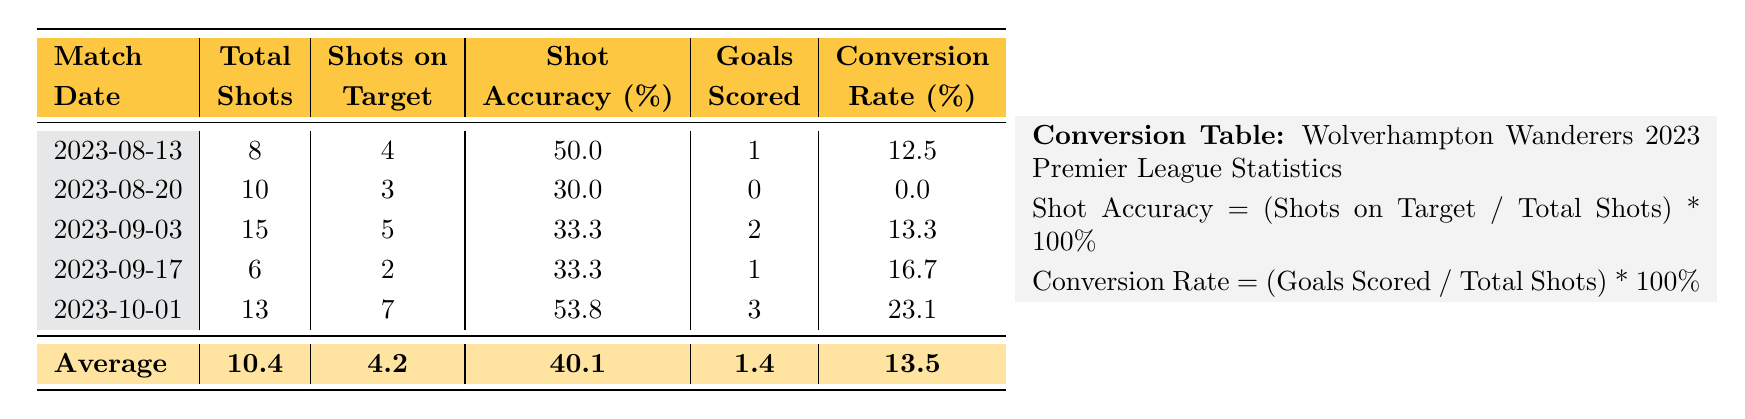What was the highest total number of shots taken by Wolverhampton Wanderers in a match? In the table, we look at the "Total Shots" column. The highest value is in the match on 2023-09-03 against Liverpool, where they had 15 total shots.
Answer: 15 What is the conversion rate for the match against Chelsea on 2023-10-01? The conversion rate is calculated as (Goals Scored / Total Shots) * 100%. For the match against Chelsea, Wolverhampton scored 3 goals and had 13 total shots. Thus, the conversion rate is (3 / 13) * 100 = 23.1%.
Answer: 23.1 Did Wolverhampton Wanderers achieve a higher shot accuracy against Manchester United or Aston Villa? The shot accuracy is calculated from the "Shots on Target" divided by "Total Shots." For Manchester United, the accuracy is (4 / 8) * 100 = 50%. For Aston Villa, it is (3 / 10) * 100 = 30%. Since 50% is greater than 30%, they had higher accuracy against Manchester United.
Answer: Yes What is the average goals scored per match across the five matches reported? To find the average goals, sum the total goals scored in all matches: (1 + 0 + 2 + 1 + 3) = 7. Divide by the number of matches (5) to get the average: 7 / 5 = 1.4.
Answer: 1.4 How many matches did Wolverhampton Wanderers not score any goals? By examining the "Goals Scored" column, we see that they scored 0 goals in the match against Aston Villa on 2023-08-20. So there is 1 match where they did not score.
Answer: 1 